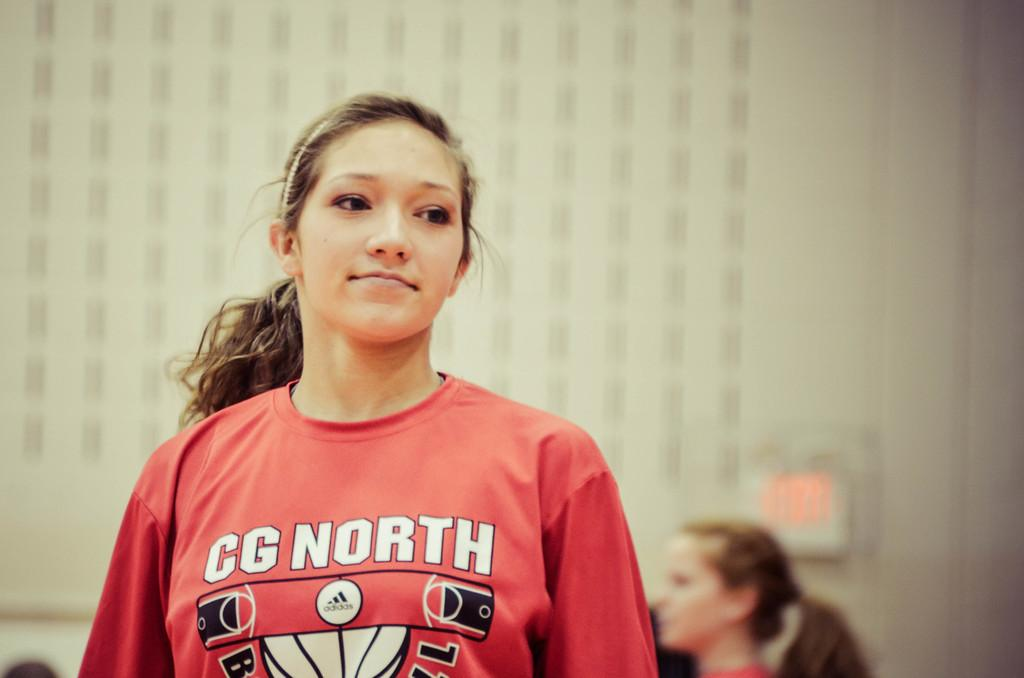<image>
Create a compact narrative representing the image presented. A girl is wearing a CG North shirt with a basketball court on it. 